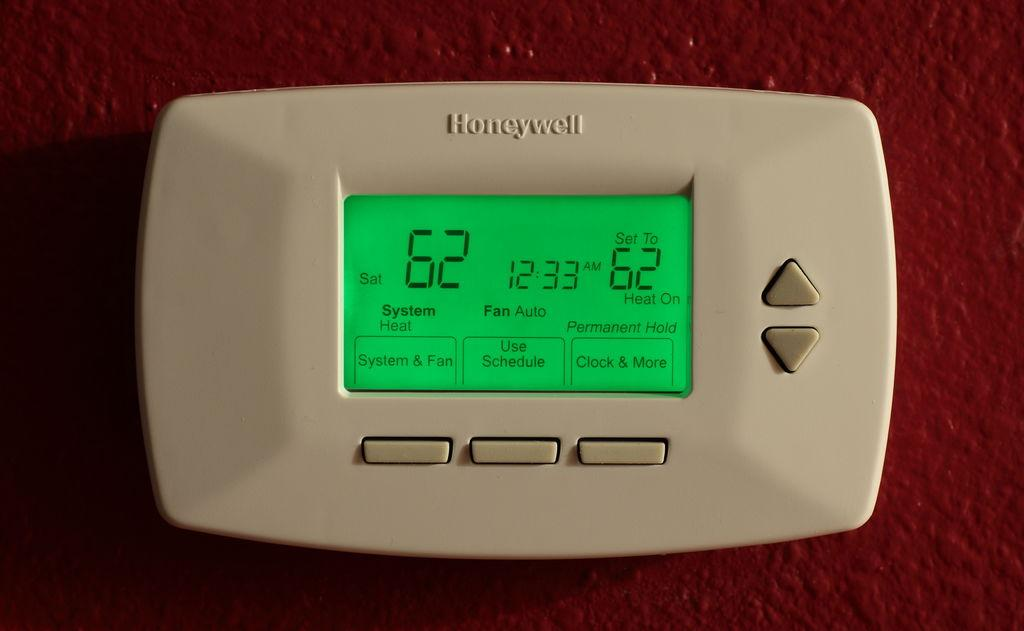<image>
Summarize the visual content of the image. The Honeywell is set to 62 degrees at 12:33 AM. 